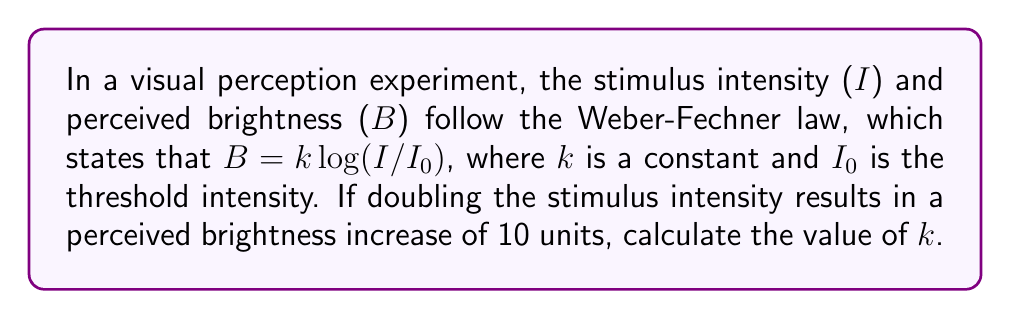Help me with this question. Let's approach this step-by-step:

1) The Weber-Fechner law is given by:
   $B = k \log(I/I_0)$

2) We're told that doubling the intensity increases brightness by 10 units. Let's express this mathematically:
   $B_2 - B_1 = 10$
   where $B_2$ is the brightness at double intensity and $B_1$ is the original brightness.

3) Let's express $B_2$ and $B_1$ using the Weber-Fechner law:
   $B_2 = k \log(2I/I_0)$
   $B_1 = k \log(I/I_0)$

4) Substituting these into our equation from step 2:
   $k \log(2I/I_0) - k \log(I/I_0) = 10$

5) Using the logarithm property $\log(a) - \log(b) = \log(a/b)$:
   $k \log((2I/I_0) / (I/I_0)) = 10$

6) Simplify inside the logarithm:
   $k \log(2) = 10$

7) Solve for $k$:
   $k = 10 / \log(2)$

8) Using a calculator or knowing that $\log(2) \approx 0.301$:
   $k \approx 10 / 0.301 \approx 33.22$
Answer: $k \approx 33.22$ 